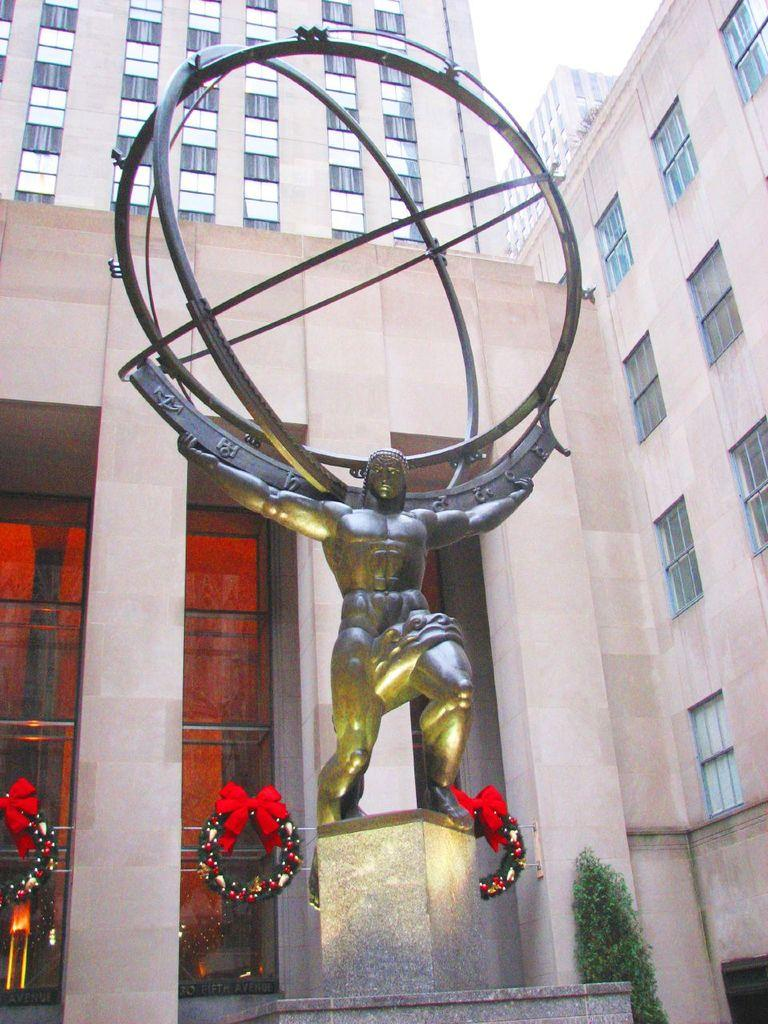What is the main subject in the image? There is a statue in the image. What decorative items can be seen in the image? There are garlands in the image. What can be seen in the background of the image? There are trees and buildings in the background of the image. What type of engine is powering the statue in the image? There is no engine present in the image, as the statue is not a vehicle or machine. 